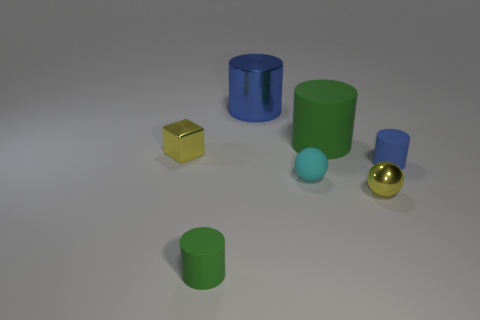Add 1 tiny metal things. How many objects exist? 8 Subtract all spheres. How many objects are left? 5 Subtract 0 purple blocks. How many objects are left? 7 Subtract all small blue cylinders. Subtract all small cyan balls. How many objects are left? 5 Add 4 small green cylinders. How many small green cylinders are left? 5 Add 7 blue cylinders. How many blue cylinders exist? 9 